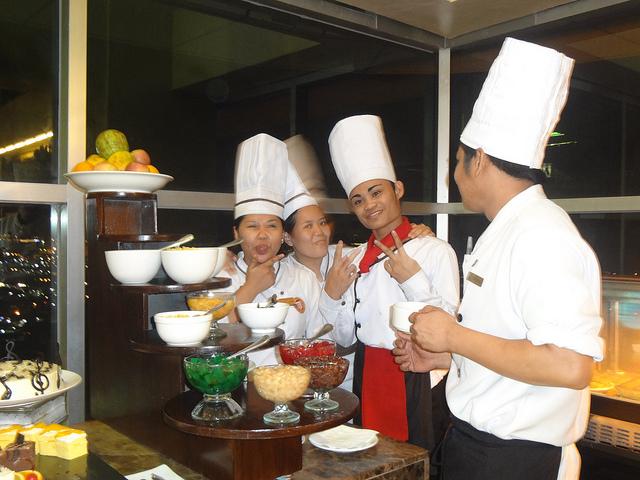Do these people perform their job primarily indoors?
Write a very short answer. Yes. How many chefs are in this scene?
Be succinct. 4. What is the chef doing?
Write a very short answer. Posing. What is the profession of these people?
Be succinct. Chef. 